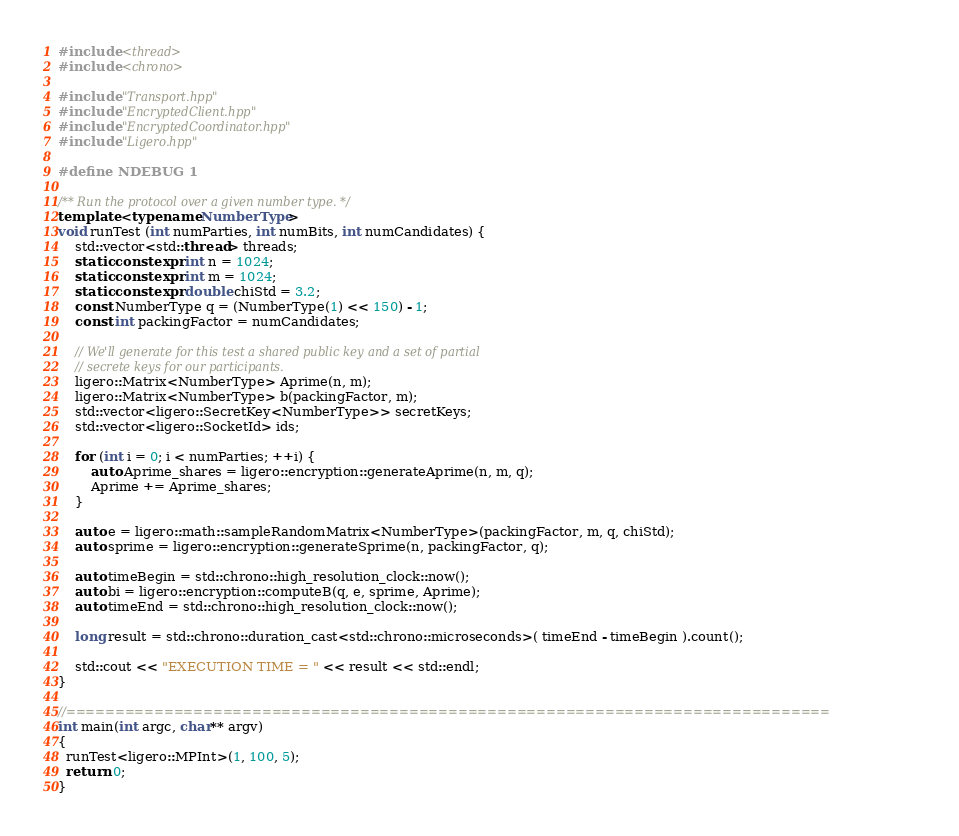Convert code to text. <code><loc_0><loc_0><loc_500><loc_500><_C++_>#include <thread>
#include <chrono>

#include "Transport.hpp"
#include "EncryptedClient.hpp"
#include "EncryptedCoordinator.hpp"
#include "Ligero.hpp"

#define NDEBUG 1

/** Run the protocol over a given number type. */
template <typename NumberType>
void runTest (int numParties, int numBits, int numCandidates) {
    std::vector<std::thread> threads;
    static constexpr int n = 1024;
    static constexpr int m = 1024;
    static constexpr double chiStd = 3.2;
    const NumberType q = (NumberType(1) << 150) - 1;
    const int packingFactor = numCandidates;

    // We'll generate for this test a shared public key and a set of partial
    // secrete keys for our participants.
    ligero::Matrix<NumberType> Aprime(n, m);
    ligero::Matrix<NumberType> b(packingFactor, m);
    std::vector<ligero::SecretKey<NumberType>> secretKeys;
    std::vector<ligero::SocketId> ids;

    for (int i = 0; i < numParties; ++i) {
        auto Aprime_shares = ligero::encryption::generateAprime(n, m, q);
        Aprime += Aprime_shares;
    }

    auto e = ligero::math::sampleRandomMatrix<NumberType>(packingFactor, m, q, chiStd);
    auto sprime = ligero::encryption::generateSprime(n, packingFactor, q);

    auto timeBegin = std::chrono::high_resolution_clock::now();
    auto bi = ligero::encryption::computeB(q, e, sprime, Aprime);
    auto timeEnd = std::chrono::high_resolution_clock::now();

    long result = std::chrono::duration_cast<std::chrono::microseconds>( timeEnd - timeBegin ).count();

    std::cout << "EXECUTION TIME = " << result << std::endl;
}

//==============================================================================
int main(int argc, char** argv)
{
  runTest<ligero::MPInt>(1, 100, 5);
  return 0;
}
</code> 